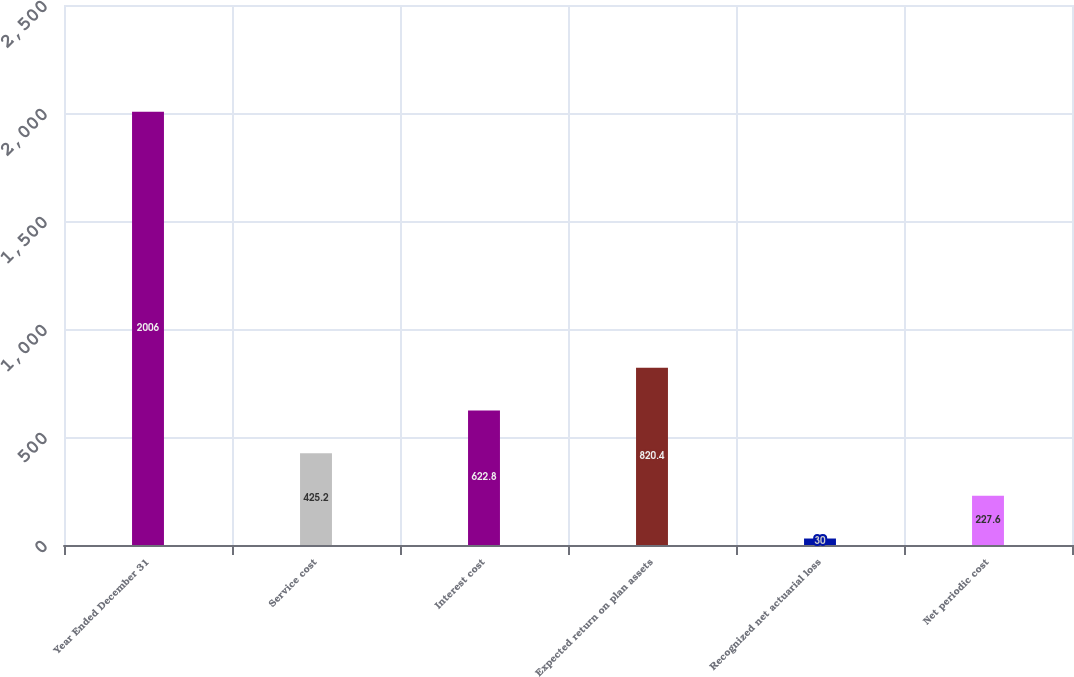Convert chart to OTSL. <chart><loc_0><loc_0><loc_500><loc_500><bar_chart><fcel>Year Ended December 31<fcel>Service cost<fcel>Interest cost<fcel>Expected return on plan assets<fcel>Recognized net actuarial loss<fcel>Net periodic cost<nl><fcel>2006<fcel>425.2<fcel>622.8<fcel>820.4<fcel>30<fcel>227.6<nl></chart> 